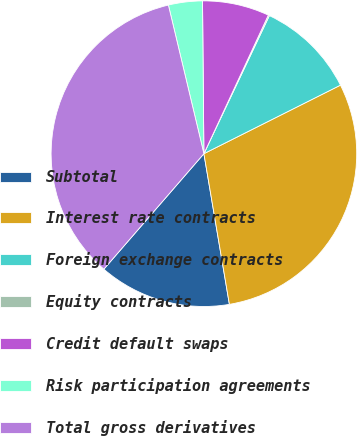Convert chart. <chart><loc_0><loc_0><loc_500><loc_500><pie_chart><fcel>Subtotal<fcel>Interest rate contracts<fcel>Foreign exchange contracts<fcel>Equity contracts<fcel>Credit default swaps<fcel>Risk participation agreements<fcel>Total gross derivatives<nl><fcel>14.03%<fcel>29.73%<fcel>10.55%<fcel>0.12%<fcel>7.07%<fcel>3.59%<fcel>34.9%<nl></chart> 